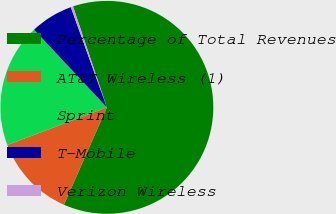Convert chart. <chart><loc_0><loc_0><loc_500><loc_500><pie_chart><fcel>Percentage of Total Revenues<fcel>AT&T Wireless (1)<fcel>Sprint<fcel>T-Mobile<fcel>Verizon Wireless<nl><fcel>61.76%<fcel>12.63%<fcel>18.77%<fcel>6.49%<fcel>0.35%<nl></chart> 